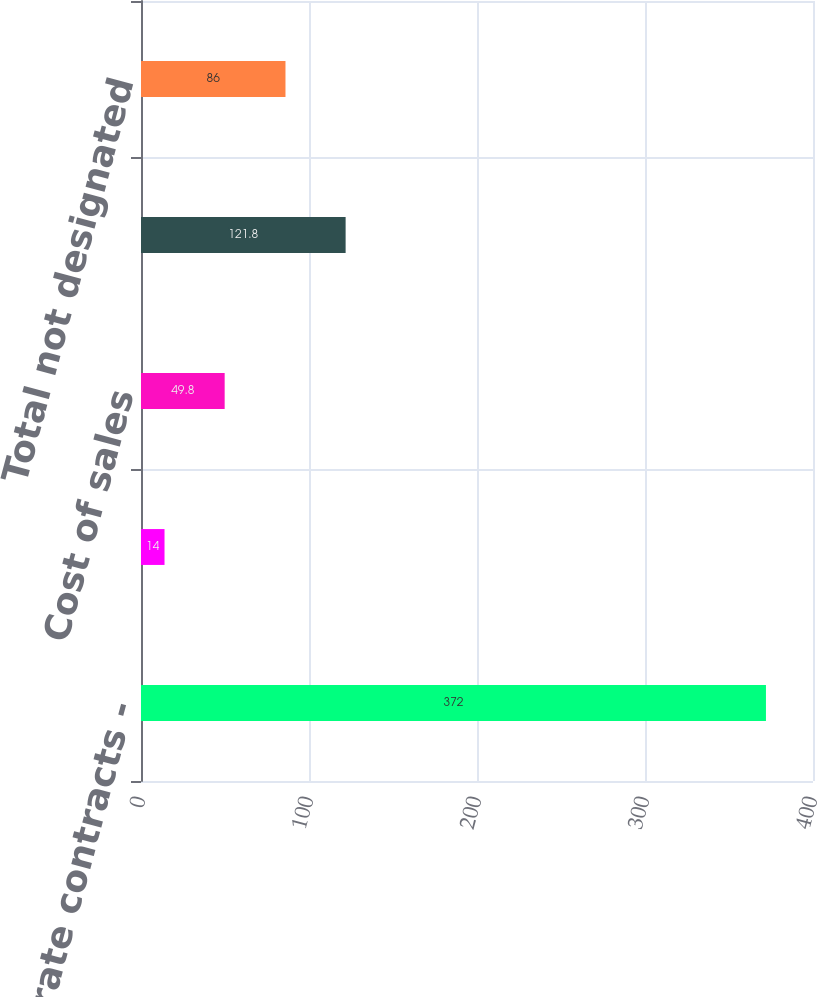Convert chart. <chart><loc_0><loc_0><loc_500><loc_500><bar_chart><fcel>Interest rate contracts -<fcel>Interest rate contracts - OCI<fcel>Cost of sales<fcel>Other expense<fcel>Total not designated<nl><fcel>372<fcel>14<fcel>49.8<fcel>121.8<fcel>86<nl></chart> 